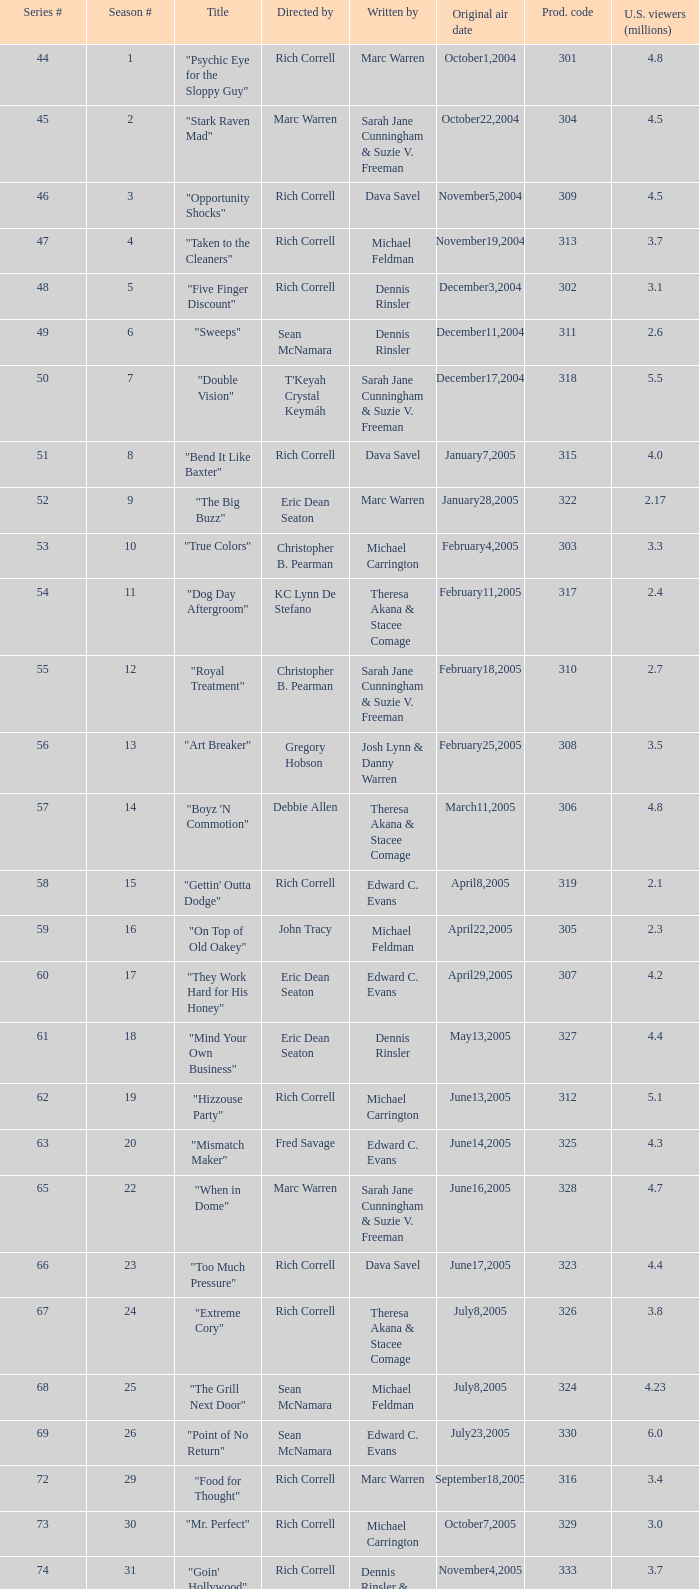What is the name of the episode directed by rich correll and penned by dennis rinsler? "Five Finger Discount". 